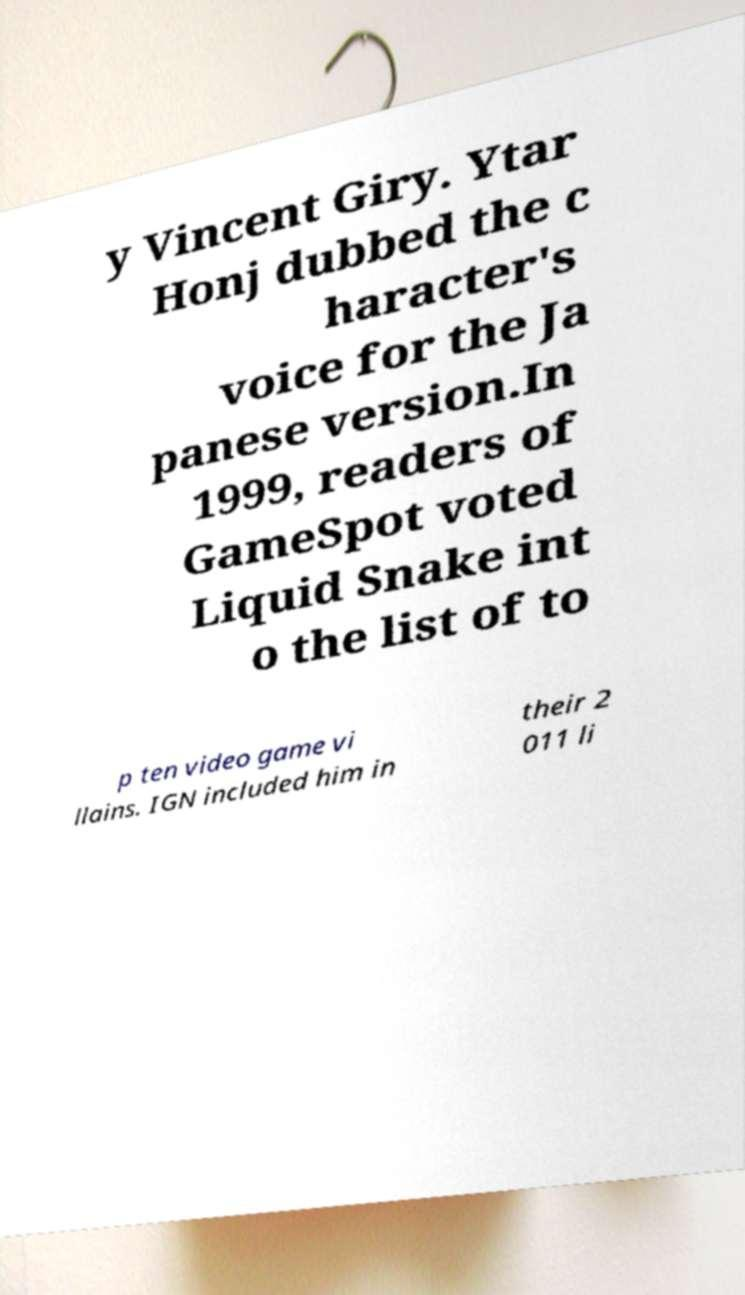Can you accurately transcribe the text from the provided image for me? y Vincent Giry. Ytar Honj dubbed the c haracter's voice for the Ja panese version.In 1999, readers of GameSpot voted Liquid Snake int o the list of to p ten video game vi llains. IGN included him in their 2 011 li 